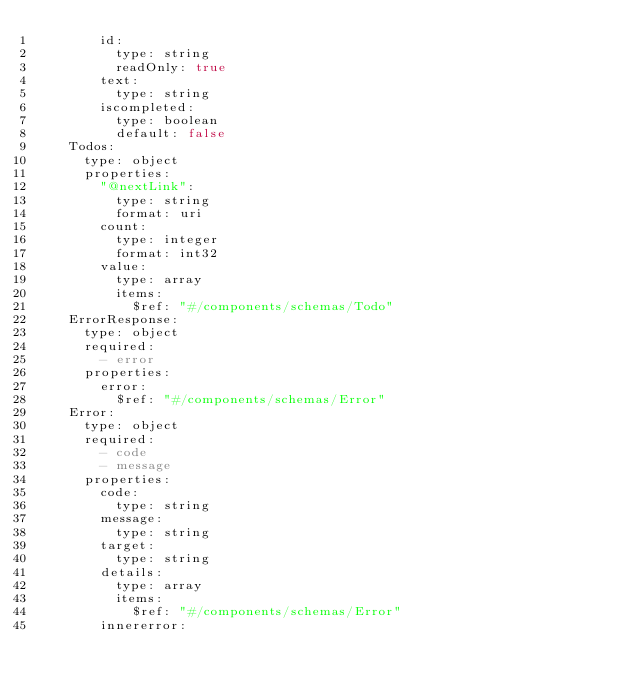<code> <loc_0><loc_0><loc_500><loc_500><_YAML_>        id:
          type: string
          readOnly: true
        text:
          type: string
        iscompleted:
          type: boolean
          default: false
    Todos:
      type: object
      properties:
        "@nextLink":
          type: string
          format: uri
        count:
          type: integer
          format: int32        
        value:
          type: array
          items:
            $ref: "#/components/schemas/Todo"
    ErrorResponse:
      type: object
      required:
        - error
      properties:
        error:
          $ref: "#/components/schemas/Error"
    Error:
      type: object
      required:
        - code
        - message
      properties:
        code:
          type: string
        message:
          type: string
        target:
          type: string
        details:
          type: array
          items:
            $ref: "#/components/schemas/Error"
        innererror:</code> 